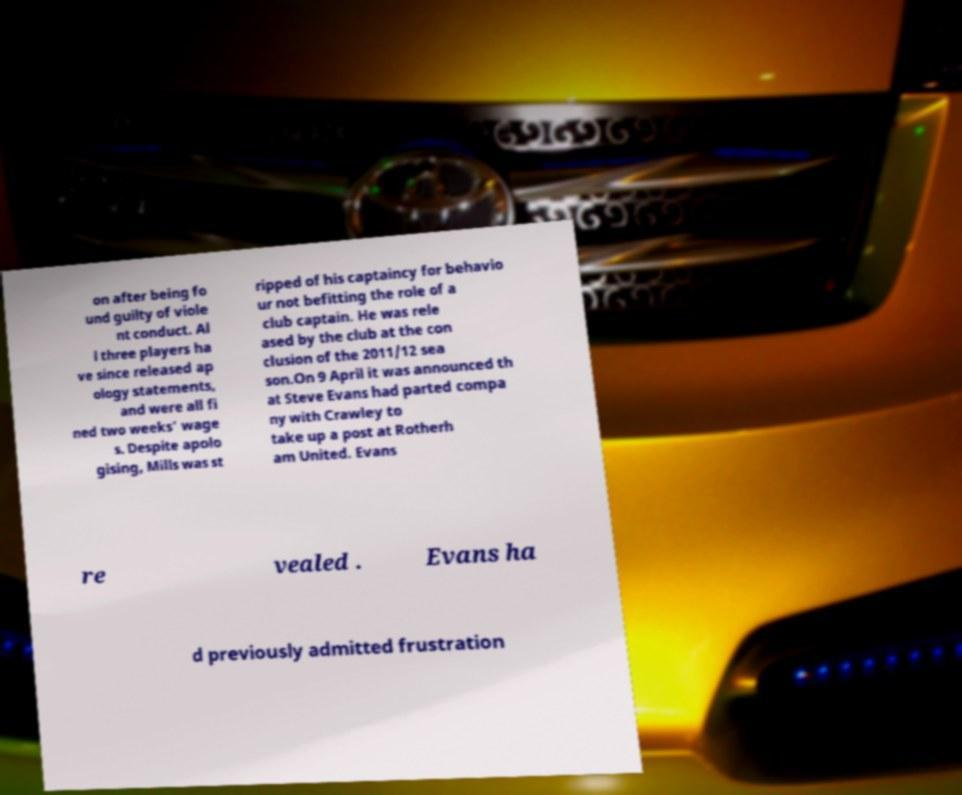Could you extract and type out the text from this image? on after being fo und guilty of viole nt conduct. Al l three players ha ve since released ap ology statements, and were all fi ned two weeks' wage s. Despite apolo gising, Mills was st ripped of his captaincy for behavio ur not befitting the role of a club captain. He was rele ased by the club at the con clusion of the 2011/12 sea son.On 9 April it was announced th at Steve Evans had parted compa ny with Crawley to take up a post at Rotherh am United. Evans re vealed . Evans ha d previously admitted frustration 